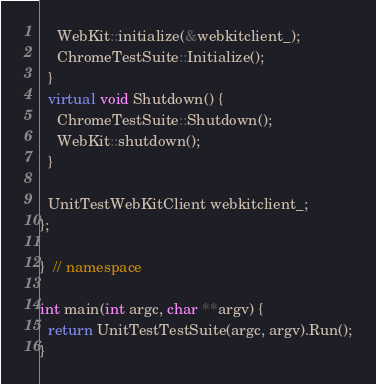<code> <loc_0><loc_0><loc_500><loc_500><_C++_>    WebKit::initialize(&webkitclient_);
    ChromeTestSuite::Initialize();
  }
  virtual void Shutdown() {
    ChromeTestSuite::Shutdown();
    WebKit::shutdown();
  }

  UnitTestWebKitClient webkitclient_;
};

}  // namespace

int main(int argc, char **argv) {
  return UnitTestTestSuite(argc, argv).Run();
}
</code> 